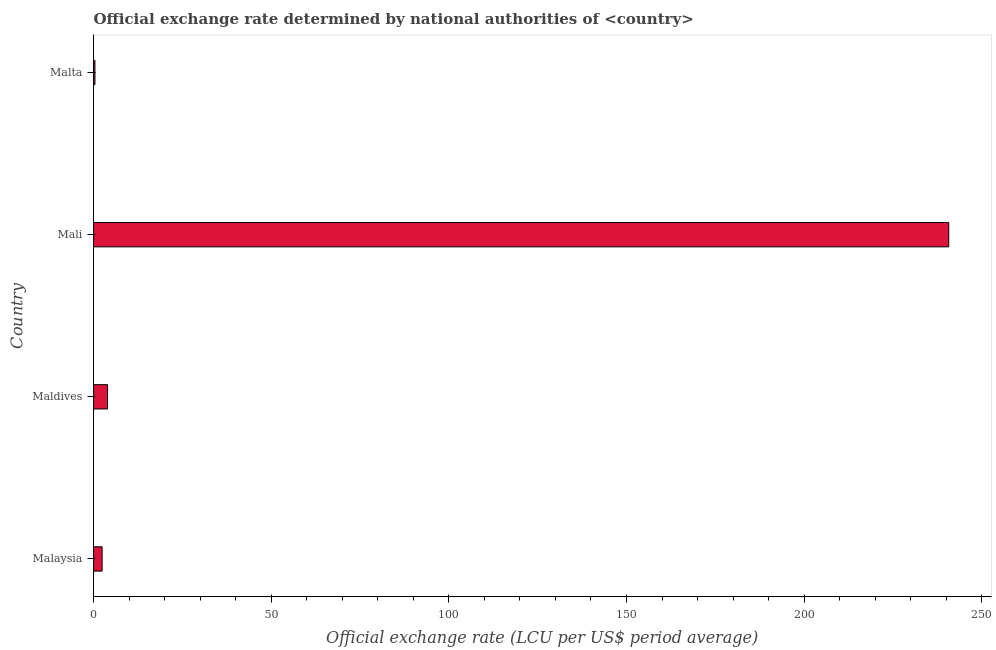Does the graph contain any zero values?
Provide a short and direct response. No. Does the graph contain grids?
Your answer should be very brief. No. What is the title of the graph?
Give a very brief answer. Official exchange rate determined by national authorities of <country>. What is the label or title of the X-axis?
Your response must be concise. Official exchange rate (LCU per US$ period average). What is the official exchange rate in Mali?
Offer a very short reply. 240.7. Across all countries, what is the maximum official exchange rate?
Provide a short and direct response. 240.7. Across all countries, what is the minimum official exchange rate?
Provide a short and direct response. 0.39. In which country was the official exchange rate maximum?
Ensure brevity in your answer.  Mali. In which country was the official exchange rate minimum?
Offer a very short reply. Malta. What is the sum of the official exchange rate?
Your answer should be very brief. 247.43. What is the difference between the official exchange rate in Malaysia and Malta?
Keep it short and to the point. 2.02. What is the average official exchange rate per country?
Your answer should be very brief. 61.86. What is the median official exchange rate?
Your answer should be very brief. 3.17. In how many countries, is the official exchange rate greater than 20 ?
Your response must be concise. 1. What is the ratio of the official exchange rate in Malaysia to that in Mali?
Your answer should be very brief. 0.01. Is the difference between the official exchange rate in Malaysia and Maldives greater than the difference between any two countries?
Offer a very short reply. No. What is the difference between the highest and the second highest official exchange rate?
Offer a very short reply. 236.78. What is the difference between the highest and the lowest official exchange rate?
Your answer should be compact. 240.32. In how many countries, is the official exchange rate greater than the average official exchange rate taken over all countries?
Keep it short and to the point. 1. How many bars are there?
Keep it short and to the point. 4. Are the values on the major ticks of X-axis written in scientific E-notation?
Ensure brevity in your answer.  No. What is the Official exchange rate (LCU per US$ period average) of Malaysia?
Provide a succinct answer. 2.41. What is the Official exchange rate (LCU per US$ period average) in Maldives?
Your answer should be compact. 3.93. What is the Official exchange rate (LCU per US$ period average) of Mali?
Your answer should be very brief. 240.7. What is the Official exchange rate (LCU per US$ period average) of Malta?
Your answer should be very brief. 0.39. What is the difference between the Official exchange rate (LCU per US$ period average) in Malaysia and Maldives?
Your answer should be compact. -1.52. What is the difference between the Official exchange rate (LCU per US$ period average) in Malaysia and Mali?
Provide a short and direct response. -238.3. What is the difference between the Official exchange rate (LCU per US$ period average) in Malaysia and Malta?
Keep it short and to the point. 2.02. What is the difference between the Official exchange rate (LCU per US$ period average) in Maldives and Mali?
Provide a succinct answer. -236.77. What is the difference between the Official exchange rate (LCU per US$ period average) in Maldives and Malta?
Offer a very short reply. 3.54. What is the difference between the Official exchange rate (LCU per US$ period average) in Mali and Malta?
Your answer should be very brief. 240.32. What is the ratio of the Official exchange rate (LCU per US$ period average) in Malaysia to that in Maldives?
Your response must be concise. 0.61. What is the ratio of the Official exchange rate (LCU per US$ period average) in Malaysia to that in Mali?
Provide a short and direct response. 0.01. What is the ratio of the Official exchange rate (LCU per US$ period average) in Malaysia to that in Malta?
Offer a terse response. 6.24. What is the ratio of the Official exchange rate (LCU per US$ period average) in Maldives to that in Mali?
Keep it short and to the point. 0.02. What is the ratio of the Official exchange rate (LCU per US$ period average) in Maldives to that in Malta?
Offer a very short reply. 10.2. What is the ratio of the Official exchange rate (LCU per US$ period average) in Mali to that in Malta?
Make the answer very short. 624.43. 